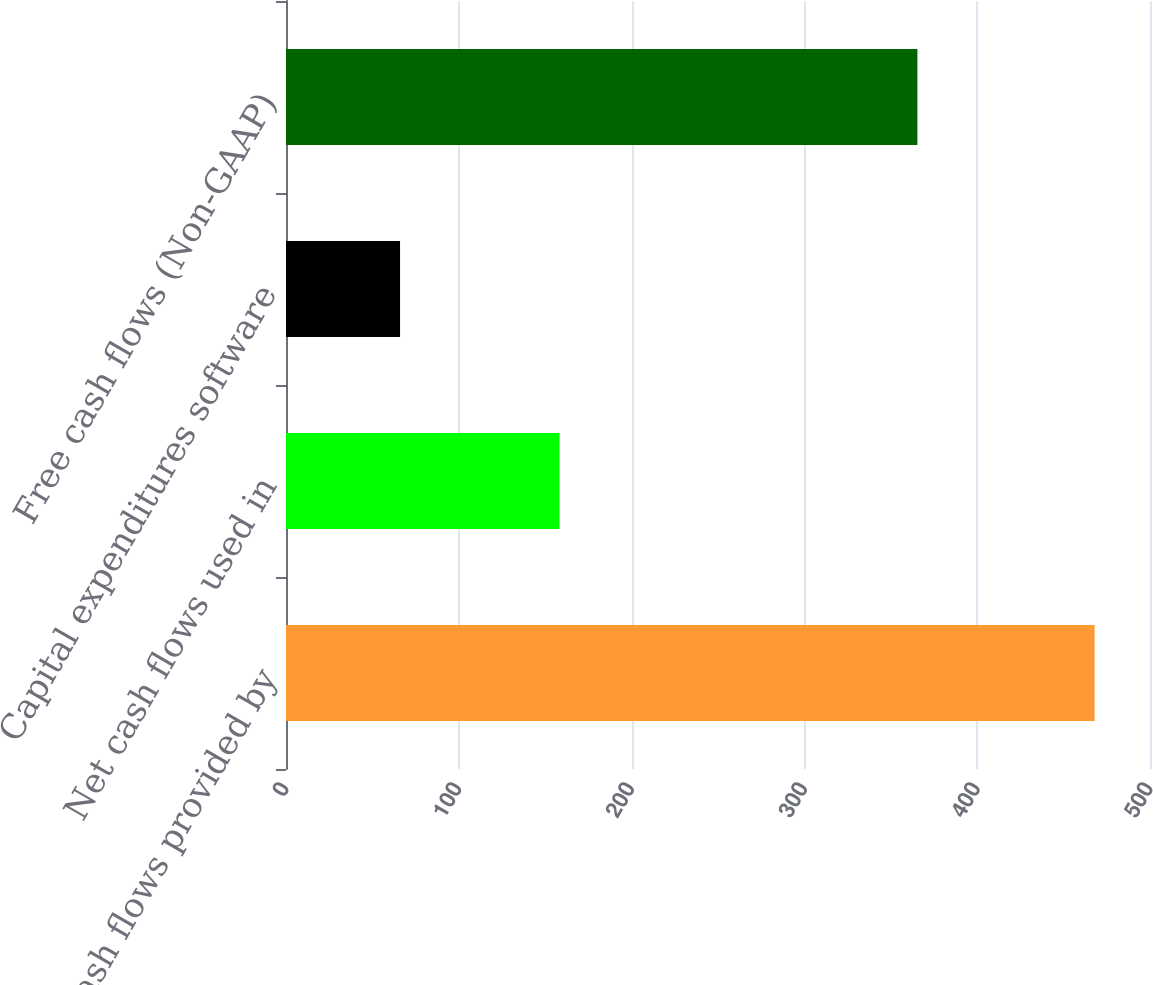<chart> <loc_0><loc_0><loc_500><loc_500><bar_chart><fcel>Net cash flows provided by<fcel>Net cash flows used in<fcel>Capital expenditures software<fcel>Free cash flows (Non-GAAP)<nl><fcel>467.94<fcel>158.3<fcel>66<fcel>365.4<nl></chart> 